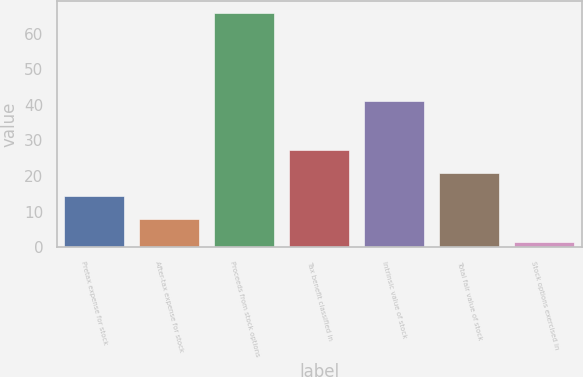<chart> <loc_0><loc_0><loc_500><loc_500><bar_chart><fcel>Pretax expense for stock<fcel>After-tax expense for stock<fcel>Proceeds from stock options<fcel>Tax benefit classified in<fcel>Intrinsic value of stock<fcel>Total fair value of stock<fcel>Stock options exercised in<nl><fcel>14.45<fcel>8<fcel>66<fcel>27.35<fcel>41<fcel>20.9<fcel>1.5<nl></chart> 